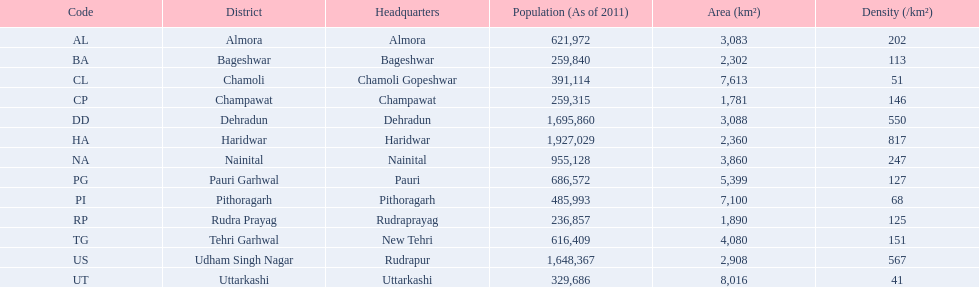Can you give me this table as a dict? {'header': ['Code', 'District', 'Headquarters', 'Population (As of 2011)', 'Area (km²)', 'Density (/km²)'], 'rows': [['AL', 'Almora', 'Almora', '621,972', '3,083', '202'], ['BA', 'Bageshwar', 'Bageshwar', '259,840', '2,302', '113'], ['CL', 'Chamoli', 'Chamoli Gopeshwar', '391,114', '7,613', '51'], ['CP', 'Champawat', 'Champawat', '259,315', '1,781', '146'], ['DD', 'Dehradun', 'Dehradun', '1,695,860', '3,088', '550'], ['HA', 'Haridwar', 'Haridwar', '1,927,029', '2,360', '817'], ['NA', 'Nainital', 'Nainital', '955,128', '3,860', '247'], ['PG', 'Pauri Garhwal', 'Pauri', '686,572', '5,399', '127'], ['PI', 'Pithoragarh', 'Pithoragarh', '485,993', '7,100', '68'], ['RP', 'Rudra Prayag', 'Rudraprayag', '236,857', '1,890', '125'], ['TG', 'Tehri Garhwal', 'New Tehri', '616,409', '4,080', '151'], ['US', 'Udham Singh Nagar', 'Rudrapur', '1,648,367', '2,908', '567'], ['UT', 'Uttarkashi', 'Uttarkashi', '329,686', '8,016', '41']]} Which has a larger population, dehradun or nainital? Dehradun. 